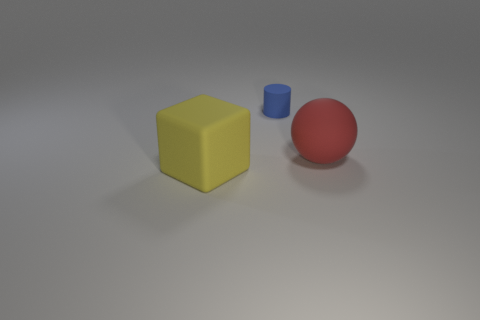Subtract all blocks. How many objects are left? 2 Subtract 1 spheres. How many spheres are left? 0 Subtract all gray blocks. How many cyan spheres are left? 0 Subtract all big red spheres. Subtract all small blue objects. How many objects are left? 1 Add 3 matte balls. How many matte balls are left? 4 Add 2 blue matte cylinders. How many blue matte cylinders exist? 3 Add 1 big cyan rubber cubes. How many objects exist? 4 Subtract 0 gray cylinders. How many objects are left? 3 Subtract all red cylinders. Subtract all purple balls. How many cylinders are left? 1 